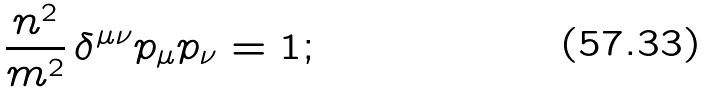<formula> <loc_0><loc_0><loc_500><loc_500>\frac { n ^ { 2 } } { m ^ { 2 } } \, \delta ^ { \mu \nu } p _ { \mu } p _ { \nu } = 1 ;</formula> 